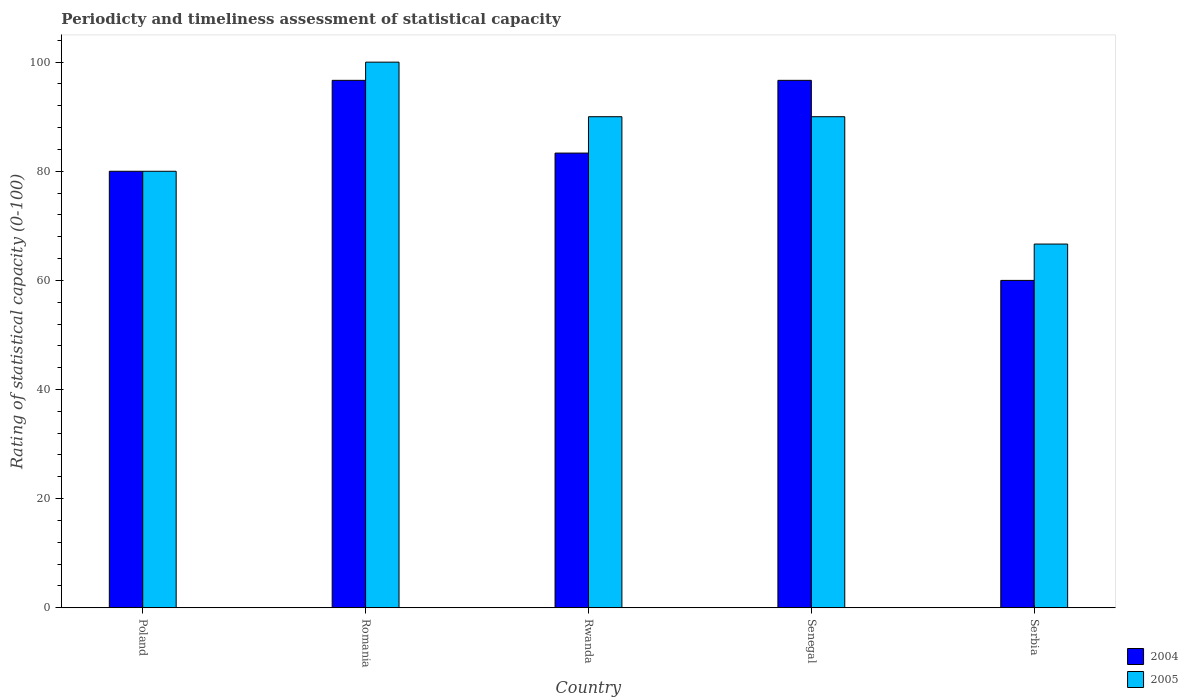How many different coloured bars are there?
Ensure brevity in your answer.  2. How many groups of bars are there?
Give a very brief answer. 5. Are the number of bars on each tick of the X-axis equal?
Ensure brevity in your answer.  Yes. How many bars are there on the 3rd tick from the right?
Offer a terse response. 2. What is the label of the 3rd group of bars from the left?
Offer a terse response. Rwanda. In how many cases, is the number of bars for a given country not equal to the number of legend labels?
Offer a very short reply. 0. Across all countries, what is the minimum rating of statistical capacity in 2004?
Give a very brief answer. 60. In which country was the rating of statistical capacity in 2005 maximum?
Ensure brevity in your answer.  Romania. In which country was the rating of statistical capacity in 2004 minimum?
Provide a short and direct response. Serbia. What is the total rating of statistical capacity in 2004 in the graph?
Make the answer very short. 416.67. What is the difference between the rating of statistical capacity in 2004 in Poland and that in Rwanda?
Your response must be concise. -3.33. What is the difference between the rating of statistical capacity in 2004 in Rwanda and the rating of statistical capacity in 2005 in Serbia?
Make the answer very short. 16.67. What is the average rating of statistical capacity in 2004 per country?
Give a very brief answer. 83.33. What is the difference between the rating of statistical capacity of/in 2004 and rating of statistical capacity of/in 2005 in Rwanda?
Your answer should be very brief. -6.67. In how many countries, is the rating of statistical capacity in 2005 greater than 12?
Give a very brief answer. 5. What is the ratio of the rating of statistical capacity in 2005 in Romania to that in Senegal?
Your answer should be compact. 1.11. Is the rating of statistical capacity in 2004 in Poland less than that in Senegal?
Ensure brevity in your answer.  Yes. What is the difference between the highest and the second highest rating of statistical capacity in 2005?
Provide a short and direct response. -10. What is the difference between the highest and the lowest rating of statistical capacity in 2004?
Your response must be concise. 36.67. How many bars are there?
Offer a very short reply. 10. What is the difference between two consecutive major ticks on the Y-axis?
Ensure brevity in your answer.  20. Are the values on the major ticks of Y-axis written in scientific E-notation?
Offer a terse response. No. Does the graph contain any zero values?
Offer a terse response. No. How many legend labels are there?
Give a very brief answer. 2. How are the legend labels stacked?
Ensure brevity in your answer.  Vertical. What is the title of the graph?
Provide a short and direct response. Periodicty and timeliness assessment of statistical capacity. What is the label or title of the X-axis?
Your response must be concise. Country. What is the label or title of the Y-axis?
Provide a short and direct response. Rating of statistical capacity (0-100). What is the Rating of statistical capacity (0-100) of 2004 in Poland?
Offer a very short reply. 80. What is the Rating of statistical capacity (0-100) in 2004 in Romania?
Offer a very short reply. 96.67. What is the Rating of statistical capacity (0-100) in 2005 in Romania?
Make the answer very short. 100. What is the Rating of statistical capacity (0-100) of 2004 in Rwanda?
Your response must be concise. 83.33. What is the Rating of statistical capacity (0-100) in 2004 in Senegal?
Provide a succinct answer. 96.67. What is the Rating of statistical capacity (0-100) in 2005 in Senegal?
Your response must be concise. 90. What is the Rating of statistical capacity (0-100) in 2004 in Serbia?
Your answer should be compact. 60. What is the Rating of statistical capacity (0-100) in 2005 in Serbia?
Offer a terse response. 66.66. Across all countries, what is the maximum Rating of statistical capacity (0-100) of 2004?
Ensure brevity in your answer.  96.67. Across all countries, what is the maximum Rating of statistical capacity (0-100) in 2005?
Offer a very short reply. 100. Across all countries, what is the minimum Rating of statistical capacity (0-100) in 2005?
Your answer should be very brief. 66.66. What is the total Rating of statistical capacity (0-100) in 2004 in the graph?
Your answer should be very brief. 416.67. What is the total Rating of statistical capacity (0-100) of 2005 in the graph?
Offer a very short reply. 426.66. What is the difference between the Rating of statistical capacity (0-100) of 2004 in Poland and that in Romania?
Offer a very short reply. -16.67. What is the difference between the Rating of statistical capacity (0-100) in 2004 in Poland and that in Rwanda?
Ensure brevity in your answer.  -3.33. What is the difference between the Rating of statistical capacity (0-100) in 2004 in Poland and that in Senegal?
Offer a very short reply. -16.67. What is the difference between the Rating of statistical capacity (0-100) of 2005 in Poland and that in Senegal?
Make the answer very short. -10. What is the difference between the Rating of statistical capacity (0-100) in 2005 in Poland and that in Serbia?
Provide a succinct answer. 13.34. What is the difference between the Rating of statistical capacity (0-100) in 2004 in Romania and that in Rwanda?
Give a very brief answer. 13.33. What is the difference between the Rating of statistical capacity (0-100) in 2004 in Romania and that in Serbia?
Make the answer very short. 36.67. What is the difference between the Rating of statistical capacity (0-100) of 2005 in Romania and that in Serbia?
Offer a very short reply. 33.34. What is the difference between the Rating of statistical capacity (0-100) in 2004 in Rwanda and that in Senegal?
Your answer should be very brief. -13.33. What is the difference between the Rating of statistical capacity (0-100) of 2004 in Rwanda and that in Serbia?
Give a very brief answer. 23.33. What is the difference between the Rating of statistical capacity (0-100) of 2005 in Rwanda and that in Serbia?
Your answer should be compact. 23.34. What is the difference between the Rating of statistical capacity (0-100) of 2004 in Senegal and that in Serbia?
Keep it short and to the point. 36.67. What is the difference between the Rating of statistical capacity (0-100) in 2005 in Senegal and that in Serbia?
Provide a succinct answer. 23.34. What is the difference between the Rating of statistical capacity (0-100) in 2004 in Poland and the Rating of statistical capacity (0-100) in 2005 in Rwanda?
Your answer should be compact. -10. What is the difference between the Rating of statistical capacity (0-100) of 2004 in Poland and the Rating of statistical capacity (0-100) of 2005 in Senegal?
Ensure brevity in your answer.  -10. What is the difference between the Rating of statistical capacity (0-100) of 2004 in Poland and the Rating of statistical capacity (0-100) of 2005 in Serbia?
Provide a short and direct response. 13.34. What is the difference between the Rating of statistical capacity (0-100) of 2004 in Romania and the Rating of statistical capacity (0-100) of 2005 in Rwanda?
Your answer should be compact. 6.67. What is the difference between the Rating of statistical capacity (0-100) of 2004 in Romania and the Rating of statistical capacity (0-100) of 2005 in Senegal?
Ensure brevity in your answer.  6.67. What is the difference between the Rating of statistical capacity (0-100) in 2004 in Romania and the Rating of statistical capacity (0-100) in 2005 in Serbia?
Provide a short and direct response. 30.01. What is the difference between the Rating of statistical capacity (0-100) in 2004 in Rwanda and the Rating of statistical capacity (0-100) in 2005 in Senegal?
Your answer should be very brief. -6.67. What is the difference between the Rating of statistical capacity (0-100) of 2004 in Rwanda and the Rating of statistical capacity (0-100) of 2005 in Serbia?
Your answer should be very brief. 16.67. What is the difference between the Rating of statistical capacity (0-100) of 2004 in Senegal and the Rating of statistical capacity (0-100) of 2005 in Serbia?
Give a very brief answer. 30.01. What is the average Rating of statistical capacity (0-100) in 2004 per country?
Ensure brevity in your answer.  83.33. What is the average Rating of statistical capacity (0-100) in 2005 per country?
Your answer should be compact. 85.33. What is the difference between the Rating of statistical capacity (0-100) in 2004 and Rating of statistical capacity (0-100) in 2005 in Poland?
Give a very brief answer. 0. What is the difference between the Rating of statistical capacity (0-100) of 2004 and Rating of statistical capacity (0-100) of 2005 in Rwanda?
Your response must be concise. -6.67. What is the difference between the Rating of statistical capacity (0-100) of 2004 and Rating of statistical capacity (0-100) of 2005 in Serbia?
Ensure brevity in your answer.  -6.66. What is the ratio of the Rating of statistical capacity (0-100) of 2004 in Poland to that in Romania?
Ensure brevity in your answer.  0.83. What is the ratio of the Rating of statistical capacity (0-100) in 2005 in Poland to that in Romania?
Provide a succinct answer. 0.8. What is the ratio of the Rating of statistical capacity (0-100) in 2005 in Poland to that in Rwanda?
Your answer should be compact. 0.89. What is the ratio of the Rating of statistical capacity (0-100) of 2004 in Poland to that in Senegal?
Offer a very short reply. 0.83. What is the ratio of the Rating of statistical capacity (0-100) in 2005 in Poland to that in Senegal?
Keep it short and to the point. 0.89. What is the ratio of the Rating of statistical capacity (0-100) of 2004 in Poland to that in Serbia?
Your response must be concise. 1.33. What is the ratio of the Rating of statistical capacity (0-100) of 2005 in Poland to that in Serbia?
Make the answer very short. 1.2. What is the ratio of the Rating of statistical capacity (0-100) in 2004 in Romania to that in Rwanda?
Keep it short and to the point. 1.16. What is the ratio of the Rating of statistical capacity (0-100) in 2005 in Romania to that in Rwanda?
Offer a terse response. 1.11. What is the ratio of the Rating of statistical capacity (0-100) of 2005 in Romania to that in Senegal?
Offer a terse response. 1.11. What is the ratio of the Rating of statistical capacity (0-100) of 2004 in Romania to that in Serbia?
Ensure brevity in your answer.  1.61. What is the ratio of the Rating of statistical capacity (0-100) of 2005 in Romania to that in Serbia?
Offer a terse response. 1.5. What is the ratio of the Rating of statistical capacity (0-100) of 2004 in Rwanda to that in Senegal?
Provide a short and direct response. 0.86. What is the ratio of the Rating of statistical capacity (0-100) of 2005 in Rwanda to that in Senegal?
Provide a short and direct response. 1. What is the ratio of the Rating of statistical capacity (0-100) in 2004 in Rwanda to that in Serbia?
Offer a very short reply. 1.39. What is the ratio of the Rating of statistical capacity (0-100) in 2005 in Rwanda to that in Serbia?
Offer a terse response. 1.35. What is the ratio of the Rating of statistical capacity (0-100) of 2004 in Senegal to that in Serbia?
Keep it short and to the point. 1.61. What is the ratio of the Rating of statistical capacity (0-100) in 2005 in Senegal to that in Serbia?
Keep it short and to the point. 1.35. What is the difference between the highest and the second highest Rating of statistical capacity (0-100) of 2004?
Ensure brevity in your answer.  0. What is the difference between the highest and the lowest Rating of statistical capacity (0-100) of 2004?
Your answer should be compact. 36.67. What is the difference between the highest and the lowest Rating of statistical capacity (0-100) of 2005?
Offer a very short reply. 33.34. 